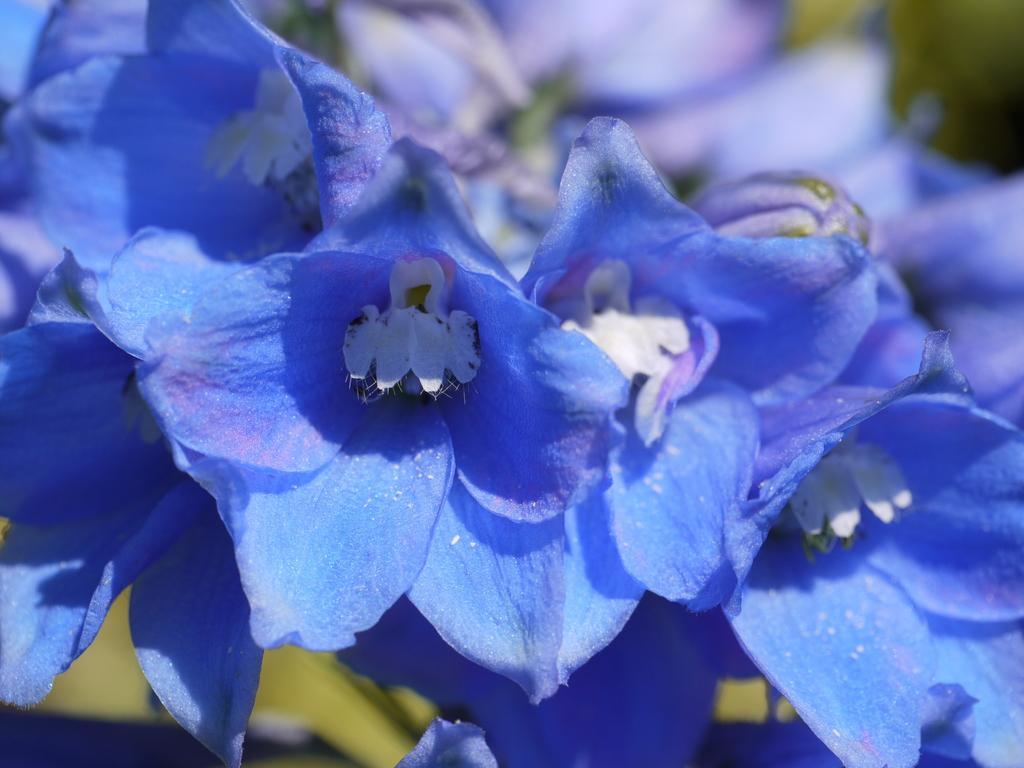In one or two sentences, can you explain what this image depicts? In this picture we can see blue flowers and in the background it is blurry. 